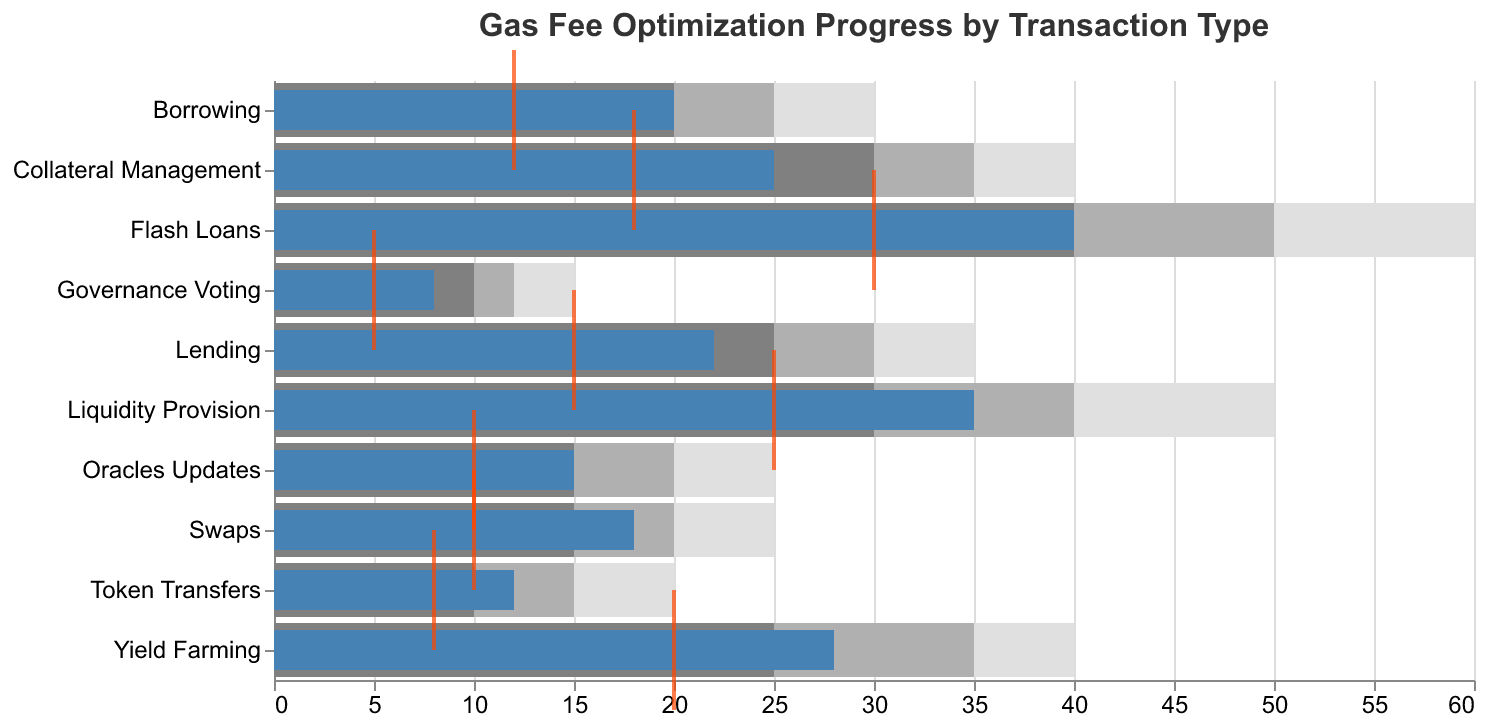What is the current gas fee for Flash Loans? By looking at the "Current" bar for Flash Loans, we see it is aligned with 40 Gwei.
Answer: 40 How many transaction types have a current gas fee higher than their target? Comparing each transaction type's "Current" bar with its "Target" tick, we see that all given transaction types have a higher current gas fee than their target.
Answer: 10 Which transaction type has the highest target gas fee? By examining the "Target" ticks, we see that Flash Loans have the highest target gas fee of 30 Gwei.
Answer: Flash Loans What is the difference between the current and target gas fee for Yield Farming? The current gas fee for Yield Farming is 28 Gwei and the target is 20 Gwei. The difference is 28 - 20 = 8 Gwei.
Answer: 8 Gwei Which transaction type is closest to reaching its target gas fee? By comparing the current gas fees to their targets, we see that Governance Voting, with a current fee of 8 Gwei and a target of 5 Gwei, is closest to its target (difference of 3 Gwei).
Answer: Governance Voting What is the average of the target gas fees for Swaps, Lending, and Token Transfers? The target gas fees are: Swaps (10 Gwei), Lending (15 Gwei), and Token Transfers (8 Gwei). The average is (10 + 15 + 8) / 3 = 11 Gwei.
Answer: 11 Gwei Which transaction type has the widest range from Range1 to Range3? Range1 to Range3 differences are calculated: Swaps (25-15=10), Liquidity Provision (50-30=20), Yield Farming (40-25=15), etc. Flash Loans have the widest range from 60 to 40 Gwei, which is 20 Gwei.
Answer: Flash Loans How many transaction types have a current gas fee within the "Range3" color bar? Checking each "Current" bar against the "Range3" values: Swaps (18 > 15), Liquidity Provision (35 > 30), Yield Farming (28 > 25), Lending (22 > 25), etc. Only Oracles Updates (15) falls within "Range3" (15).
Answer: 1 Which transaction type has the second lowest current gas fee? After Governance Voting with the lowest current fee of 8 Gwei, Token Transfers with 12 Gwei is the second lowest.
Answer: Token Transfers Which transaction type shows a current fee that exceeds even its Range1 maximum? Flash Loans have a current fee of 40 Gwei, which is also its Range1 maximum (40), but Swaps (18), Liquidity Provision (35), Yield Farming (28), etc., remain within or below their Range1 values. No current fee exceeds Range1.
Answer: None 